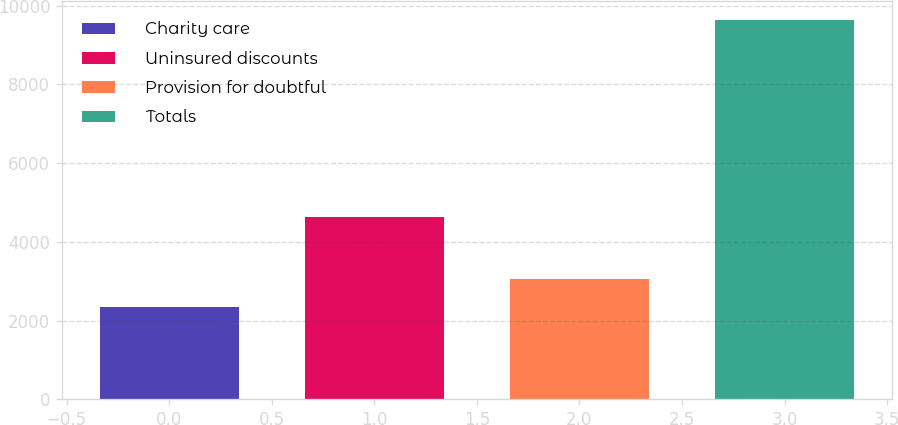Convert chart to OTSL. <chart><loc_0><loc_0><loc_500><loc_500><bar_chart><fcel>Charity care<fcel>Uninsured discounts<fcel>Provision for doubtful<fcel>Totals<nl><fcel>2337<fcel>4641<fcel>3065.9<fcel>9626<nl></chart> 